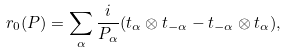<formula> <loc_0><loc_0><loc_500><loc_500>r _ { 0 } ( P ) = \sum _ { \alpha } \frac { i } { P _ { \alpha } } ( t _ { \alpha } \otimes t _ { - \alpha } - t _ { - \alpha } \otimes t _ { \alpha } ) ,</formula> 